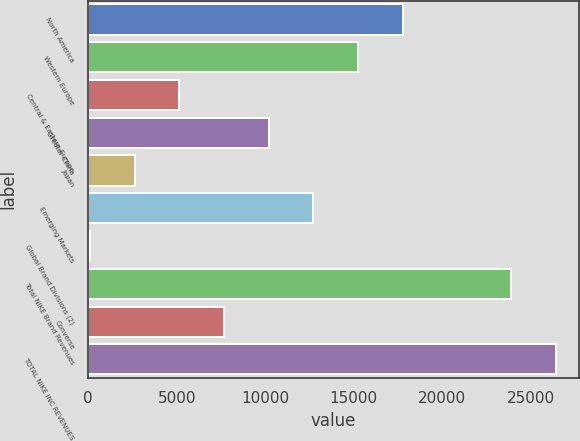Convert chart. <chart><loc_0><loc_0><loc_500><loc_500><bar_chart><fcel>North America<fcel>Western Europe<fcel>Central & Eastern Europe<fcel>Greater China<fcel>Japan<fcel>Emerging Markets<fcel>Global Brand Divisions (2)<fcel>Total NIKE Brand Revenues<fcel>Converse<fcel>TOTAL NIKE INC REVENUES<nl><fcel>17753.6<fcel>15233.8<fcel>5154.6<fcel>10194.2<fcel>2634.8<fcel>12714<fcel>115<fcel>23881<fcel>7674.4<fcel>26400.8<nl></chart> 